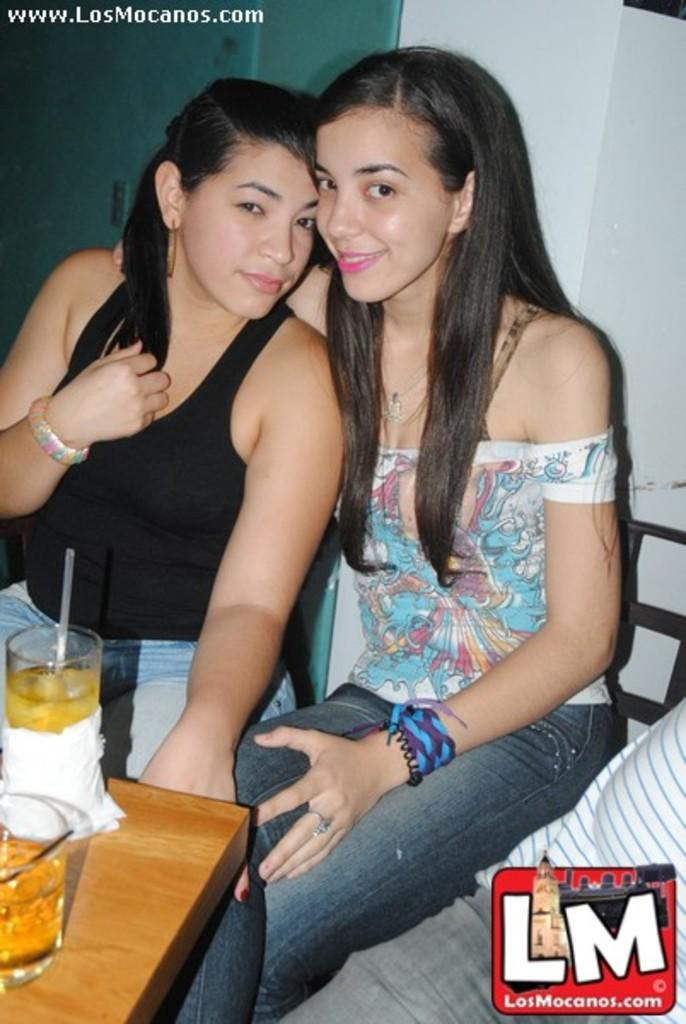How many people are in the image? There are two ladies in the image. What are the ladies doing in the image? The ladies are sitting. What is located in front of the ladies? There is a table in front of the ladies. What objects can be seen on the table? There are glasses on the table. Where is the table positioned in the image? The table is in the bottom left corner of the image. What type of desk can be seen in the image? There is no desk present in the image. What boundary is visible in the image? The image does not depict any boundaries; it shows two ladies sitting at a table. 